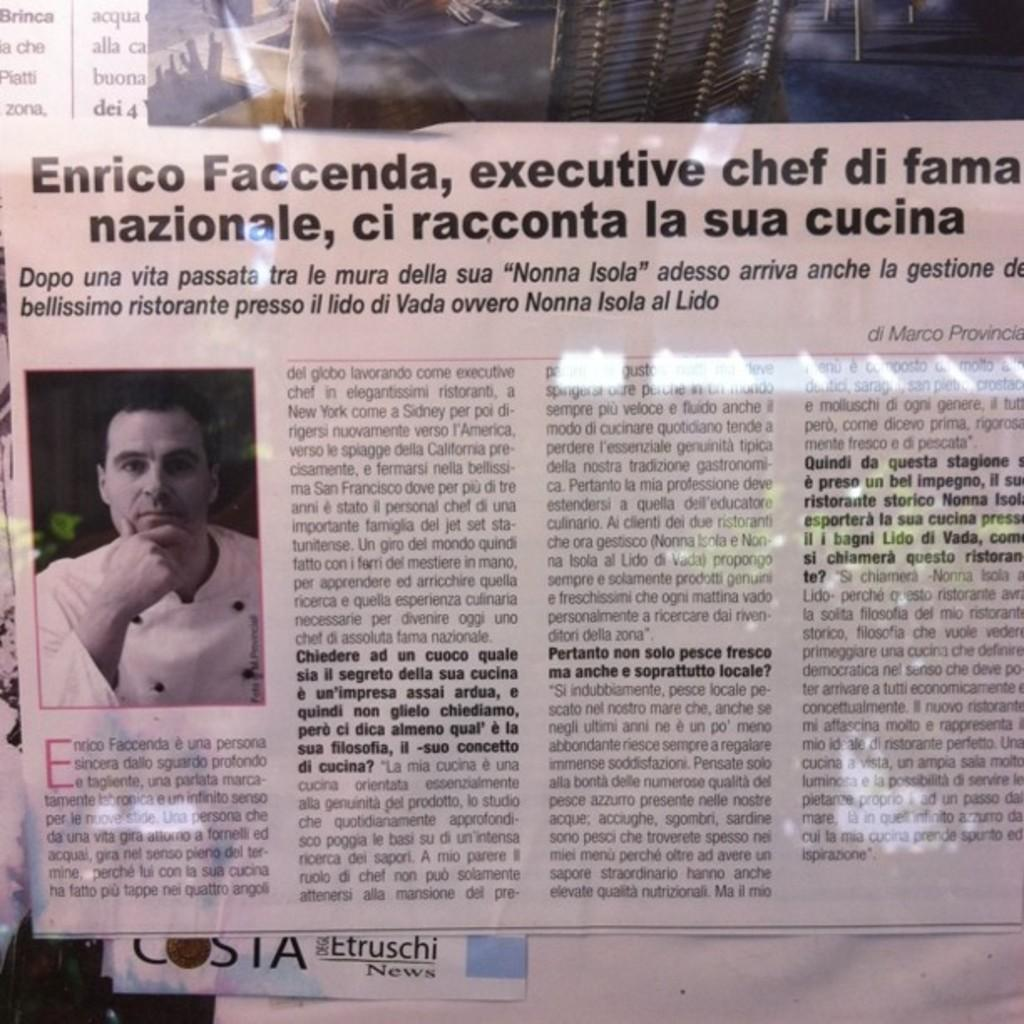What is the main subject of the newspaper picture in the image? The main subject of the newspaper picture in the image is a person. What else is present in the newspaper picture besides the person? The newspaper picture contains text. What type of dinosaurs can be seen in the newspaper picture? There are no dinosaurs present in the newspaper picture; it contains a person and text. What type of steel is used to create the sheet in the newspaper picture? There is no sheet or steel present in the newspaper picture; it only contains a person and text. 